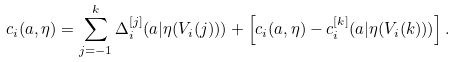<formula> <loc_0><loc_0><loc_500><loc_500>c _ { i } ( a , \eta ) = \sum _ { j = - 1 } ^ { k } \Delta ^ { [ j ] } _ { i } ( a | \eta ( V _ { i } ( j ) ) ) + \left [ c _ { i } ( a , \eta ) - c _ { i } ^ { [ k ] } ( a | \eta ( V _ { i } ( k ) ) ) \right ] .</formula> 